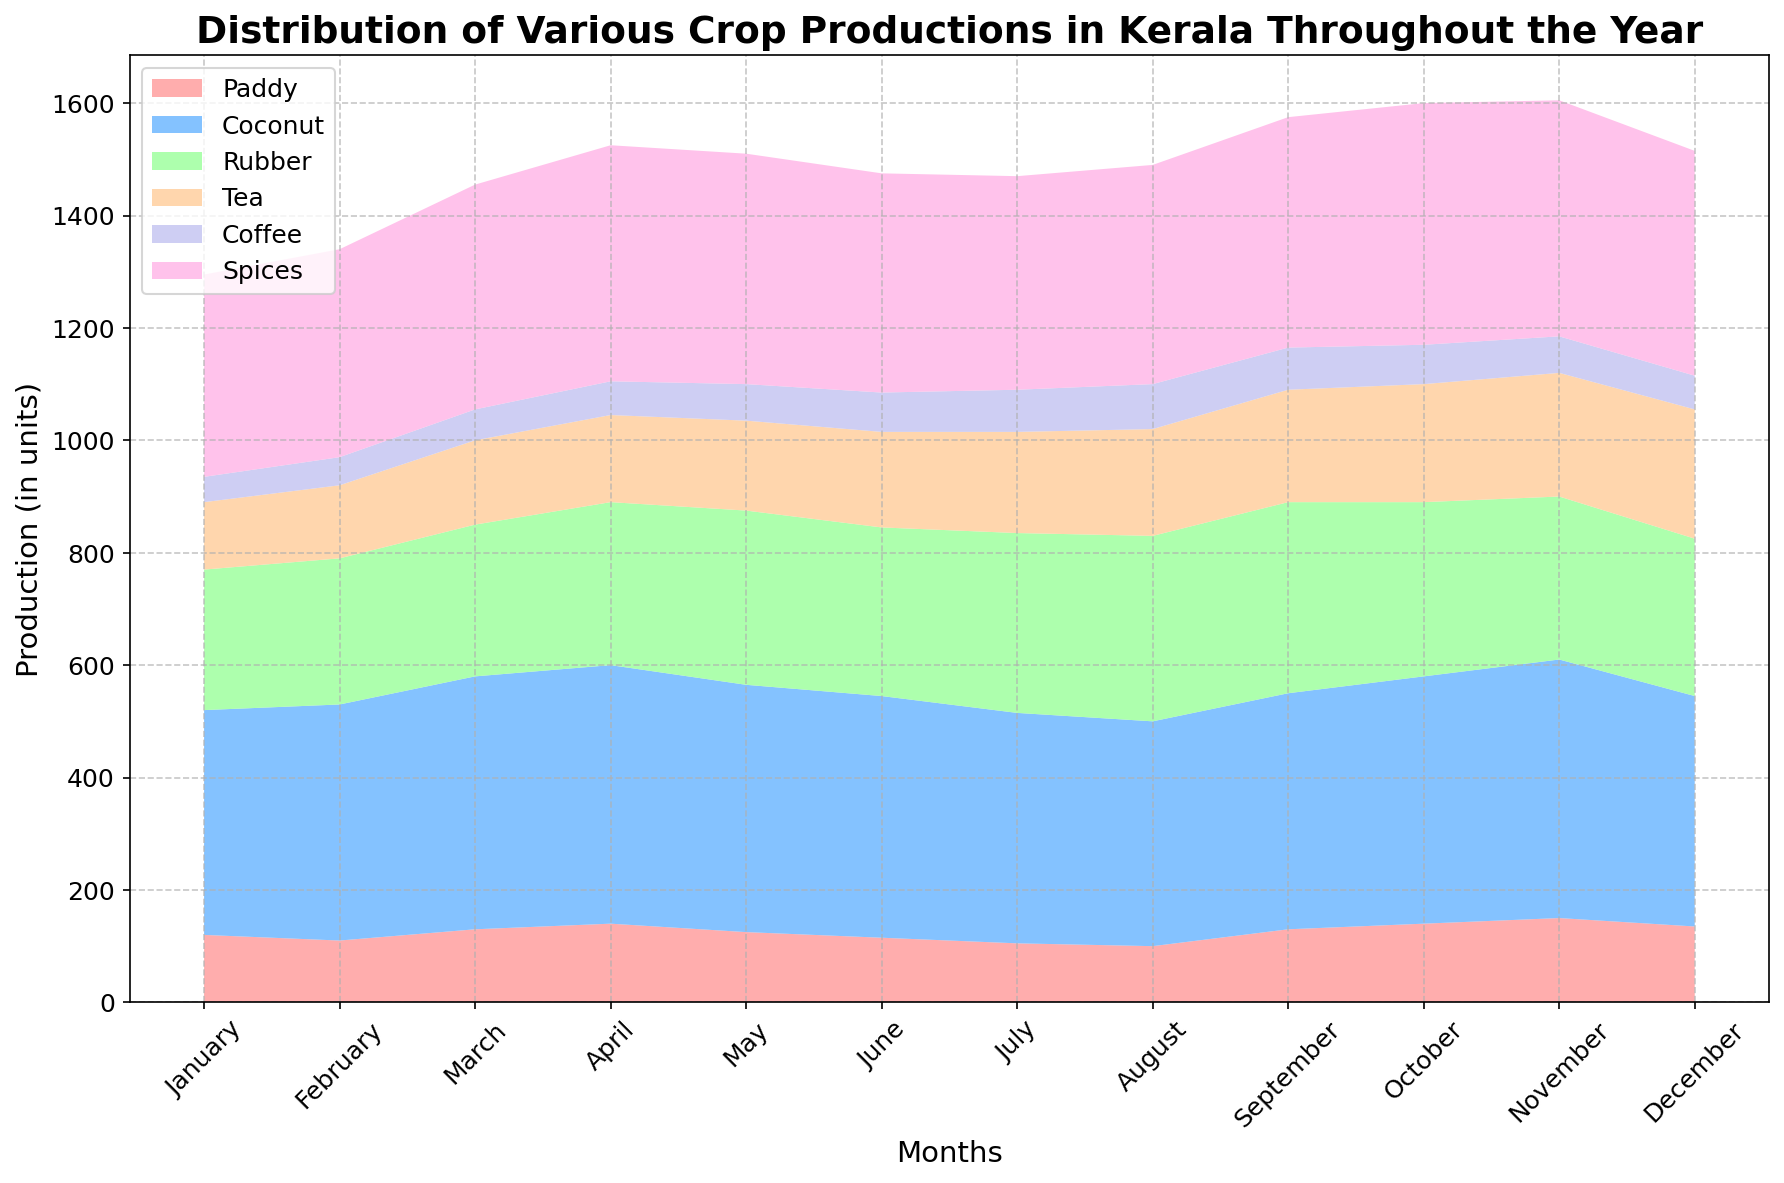Which month has the highest production of Coconut? Looking at the highest sections of the area chart for Coconut, we see that March, April, and November each have the highest peak, indicating these are the months with the highest production of Coconut.
Answer: April In which month is Paddy production the lowest? Observing the height of the section for Paddy, it appears the smallest in August.
Answer: August During which month does Tea production exceed Rubber production the most? Comparing both the Tea and Rubber sections for each month, the difference is the greatest in December.
Answer: December Which crop has the most consistent production throughout the year? By visually examining the areas where each crop has fluctuations, Coconut appears to have the most even distribution over all months compared to other crops.
Answer: Coconut What is the total production of Tea for the year? Summing up the Tea values: 120 + 130 + 150 + 155 + 160 + 170 + 180 + 190 + 200 + 210 + 220 + 230 = 2115
Answer: 2115 In which month is the production difference between Spices and Paddy the highest? By calculating the difference for each month and comparing, September shows the highest production difference between Spices and Paddy.
Answer: September Is the production trend of Coffee and Rubber similar throughout the year? Examining the visual trend of Coffee and Rubber, both show gradual increases and peaks around mid-year and then decrease, displaying a similar trend visually.
Answer: Yes Which crop shows an increase in production starting from January and peaks in July? By tracking the chart from January to July, Rubber consistently rises and peaks in July.
Answer: Rubber How many crops peak their production in September? From the visual information, only Paddy has its highest production value in September, which can be verified by checking the data on the chart.
Answer: One (Paddy) What is the visual trend for Coconut production from March to June? The visual trend for Coconut shows a slight increase from March to April, levels in May, then a slight decrease in June.
Answer: Increases, levels, then decreases 